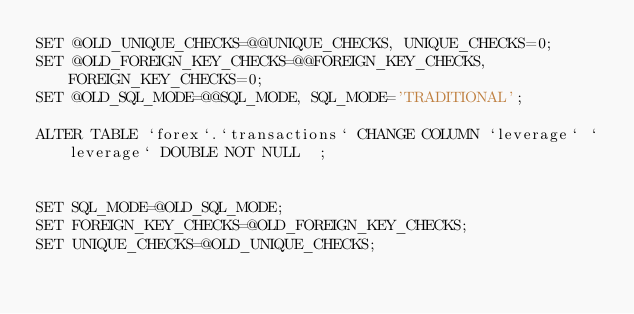<code> <loc_0><loc_0><loc_500><loc_500><_SQL_>SET @OLD_UNIQUE_CHECKS=@@UNIQUE_CHECKS, UNIQUE_CHECKS=0;
SET @OLD_FOREIGN_KEY_CHECKS=@@FOREIGN_KEY_CHECKS, FOREIGN_KEY_CHECKS=0;
SET @OLD_SQL_MODE=@@SQL_MODE, SQL_MODE='TRADITIONAL';

ALTER TABLE `forex`.`transactions` CHANGE COLUMN `leverage` `leverage` DOUBLE NOT NULL  ;


SET SQL_MODE=@OLD_SQL_MODE;
SET FOREIGN_KEY_CHECKS=@OLD_FOREIGN_KEY_CHECKS;
SET UNIQUE_CHECKS=@OLD_UNIQUE_CHECKS;
</code> 